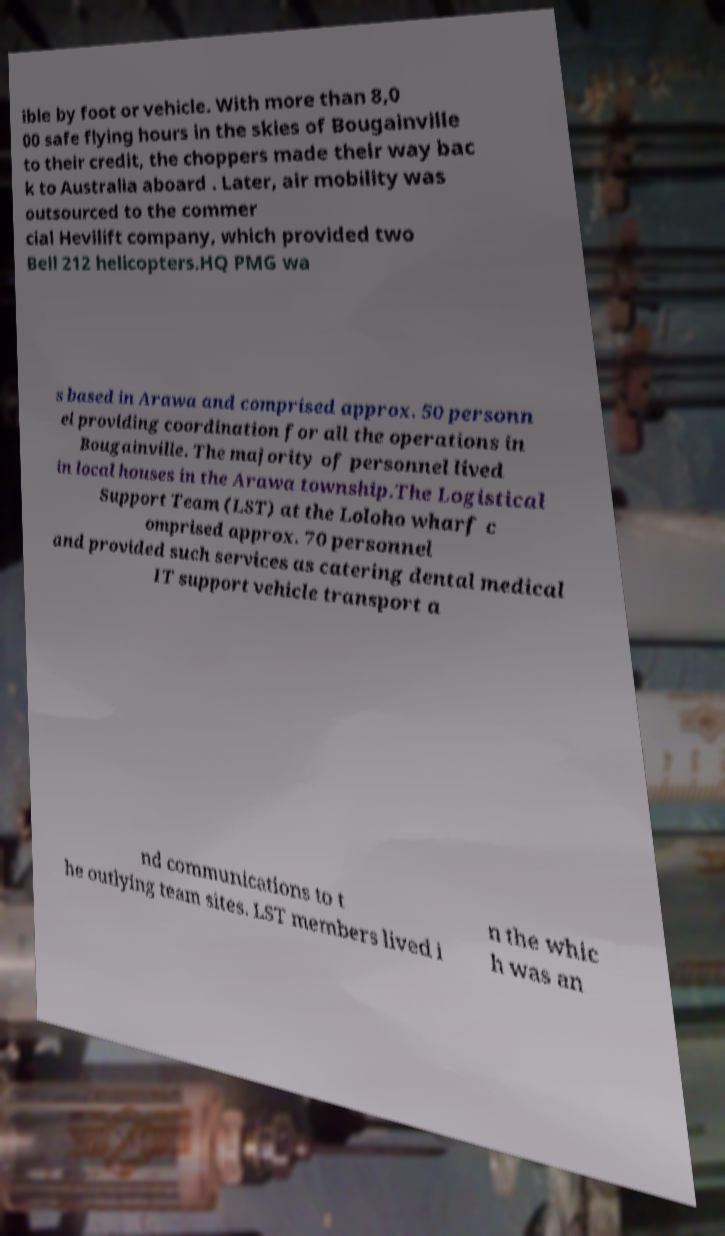Please read and relay the text visible in this image. What does it say? ible by foot or vehicle. With more than 8,0 00 safe flying hours in the skies of Bougainville to their credit, the choppers made their way bac k to Australia aboard . Later, air mobility was outsourced to the commer cial Hevilift company, which provided two Bell 212 helicopters.HQ PMG wa s based in Arawa and comprised approx. 50 personn el providing coordination for all the operations in Bougainville. The majority of personnel lived in local houses in the Arawa township.The Logistical Support Team (LST) at the Loloho wharf c omprised approx. 70 personnel and provided such services as catering dental medical IT support vehicle transport a nd communications to t he outlying team sites. LST members lived i n the whic h was an 